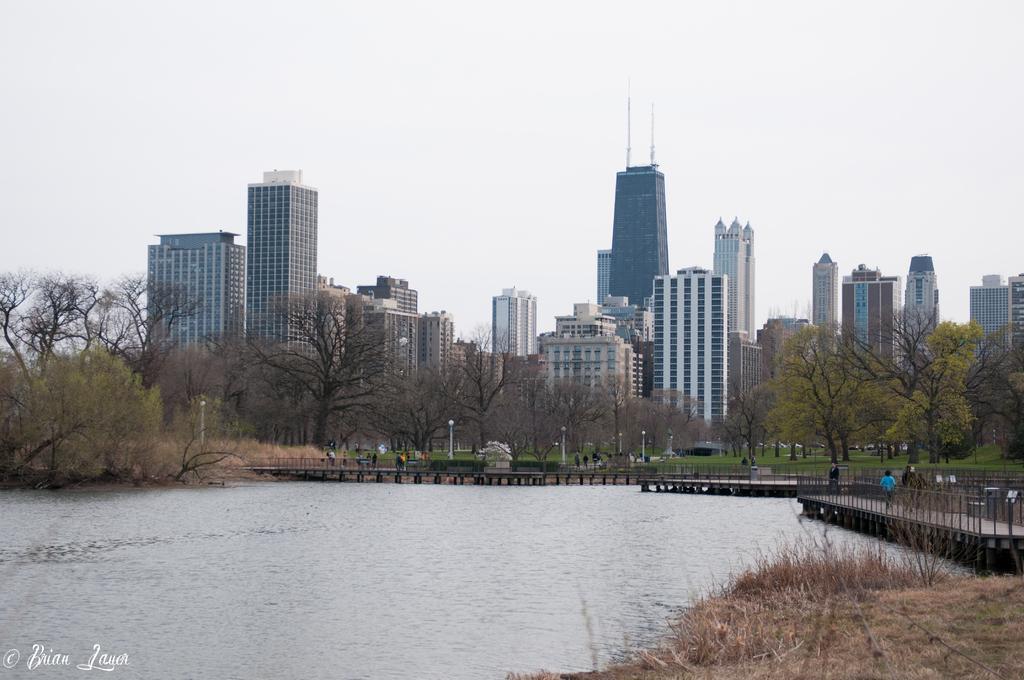Describe this image in one or two sentences. In the down side it is water. In the long back side there are trees and big buildings. 